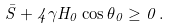<formula> <loc_0><loc_0><loc_500><loc_500>\bar { S } + 4 \gamma H _ { 0 } \cos \theta _ { 0 } \geq 0 \, .</formula> 